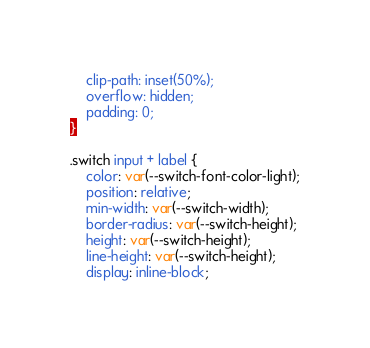Convert code to text. <code><loc_0><loc_0><loc_500><loc_500><_CSS_>    clip-path: inset(50%);
    overflow: hidden;
    padding: 0;
}

.switch input + label {
    color: var(--switch-font-color-light);
    position: relative;
    min-width: var(--switch-width);
    border-radius: var(--switch-height);
    height: var(--switch-height);
    line-height: var(--switch-height);
    display: inline-block;</code> 